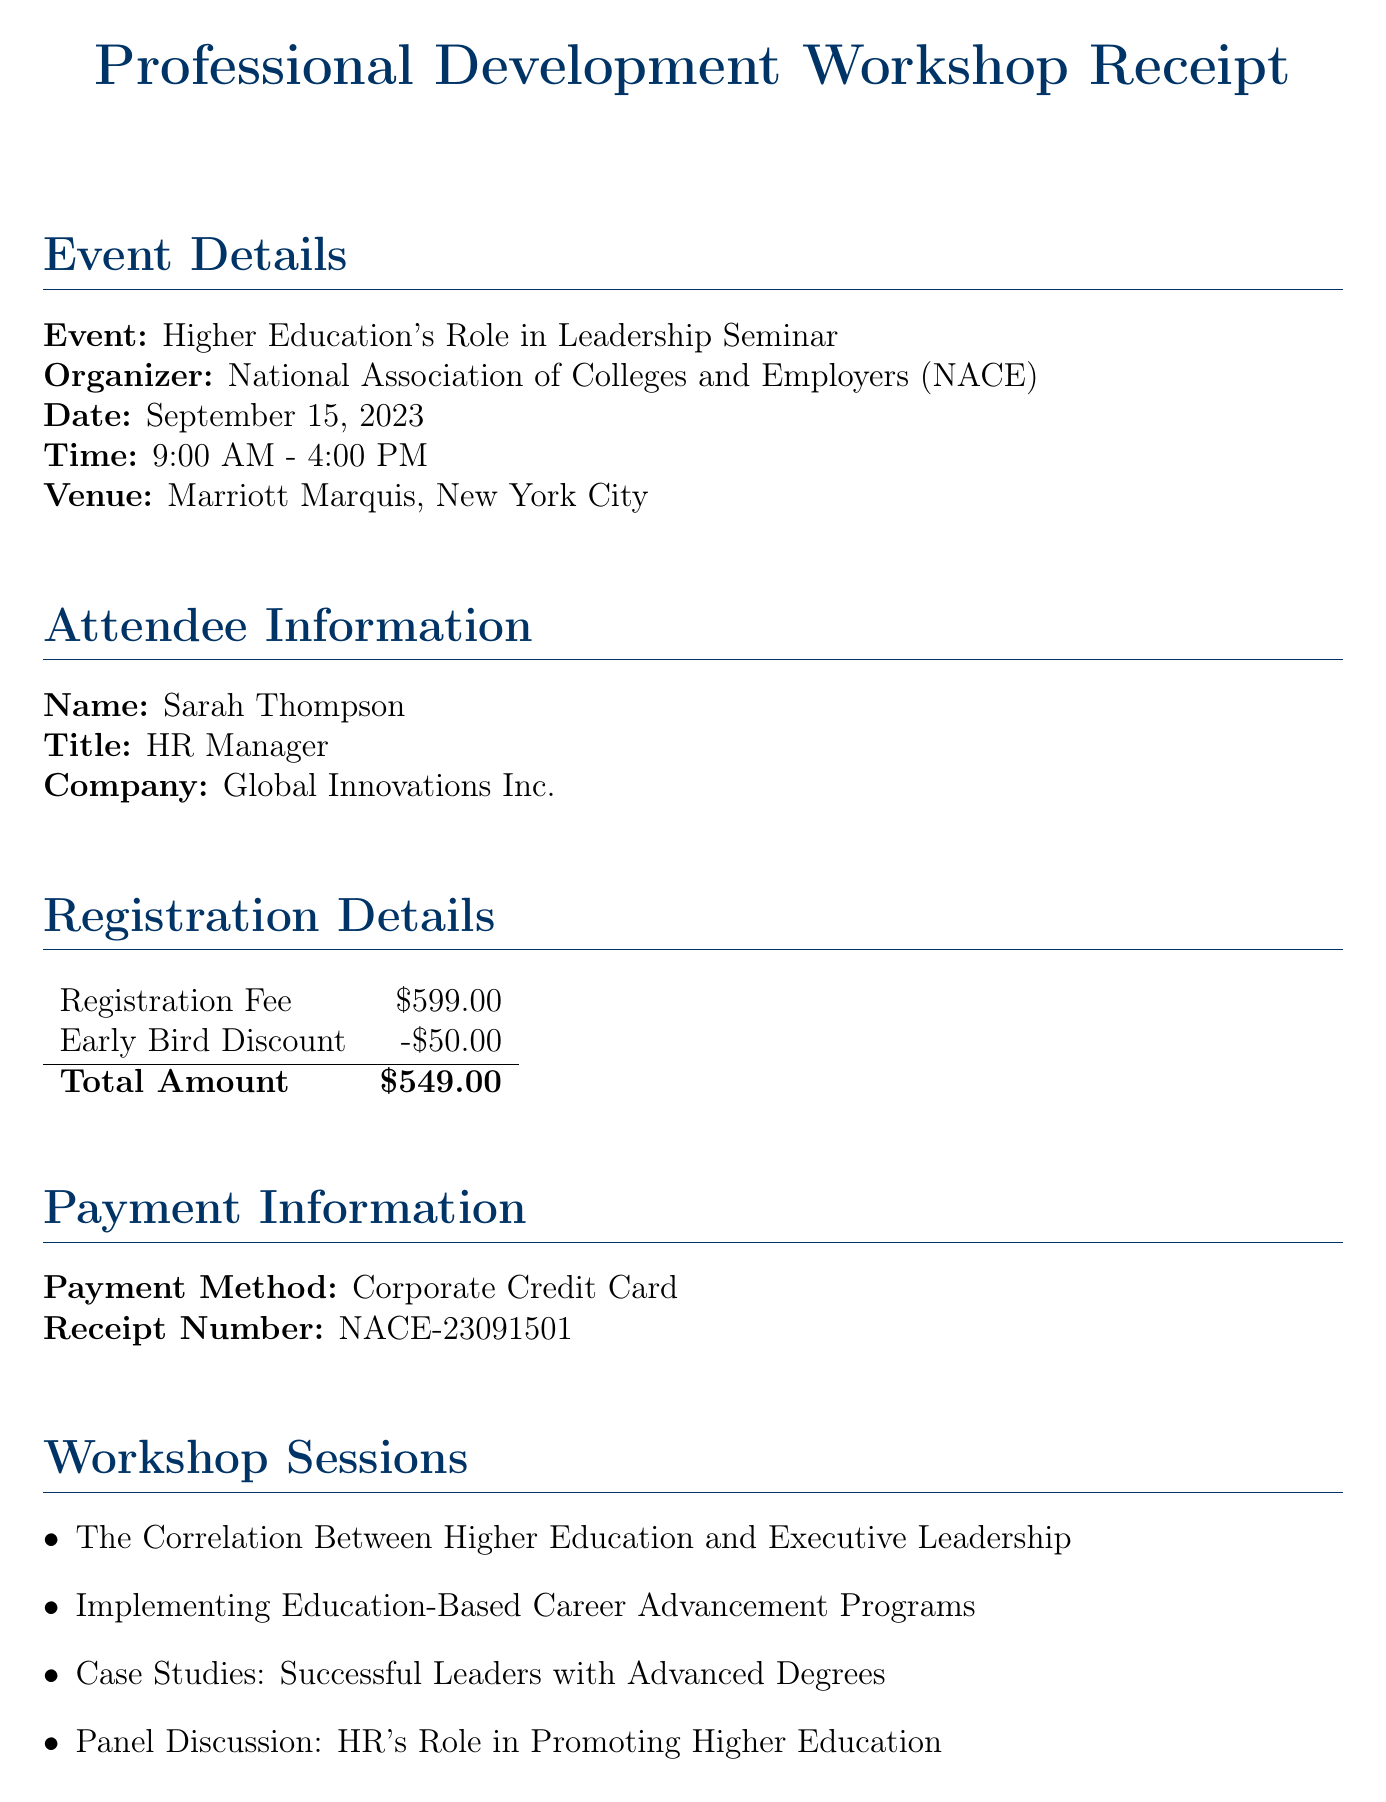What is the event name? The event name is provided in the document under the event details section.
Answer: Higher Education's Role in Leadership Seminar Who is the keynote speaker? The document lists the keynote speaker in a specific section, including their title and institution.
Answer: Dr. Elizabeth Chen What is the registration fee? The registration fee is specified in the registration details section of the document.
Answer: $599.00 What is the total amount after the early bird discount? The total amount is calculated by subtracting the early bird discount from the registration fee, as detailed in the document.
Answer: $549.00 Which company does the attendee belong to? The attendee's company is mentioned in the attendee information section of the document.
Answer: Global Innovations Inc What additional benefit is available for attendees? This question explores the additional benefits provided in the document, which offers various resources for attendees.
Answer: 1-year subscription to 'HR and Higher Education' quarterly journal How long is the access to NACE's online learning platform? The document states the duration of access to the learning platform in the additional benefits section.
Answer: 30-day What meals are catered during the seminar? Catering information outlines the meals provided during the seminar.
Answer: Continental Breakfast, Executive Networking Luncheon, All-day Coffee and Tea Service What is the date of the seminar? The date of the seminar is specified under the event details section in the document.
Answer: September 15, 2023 